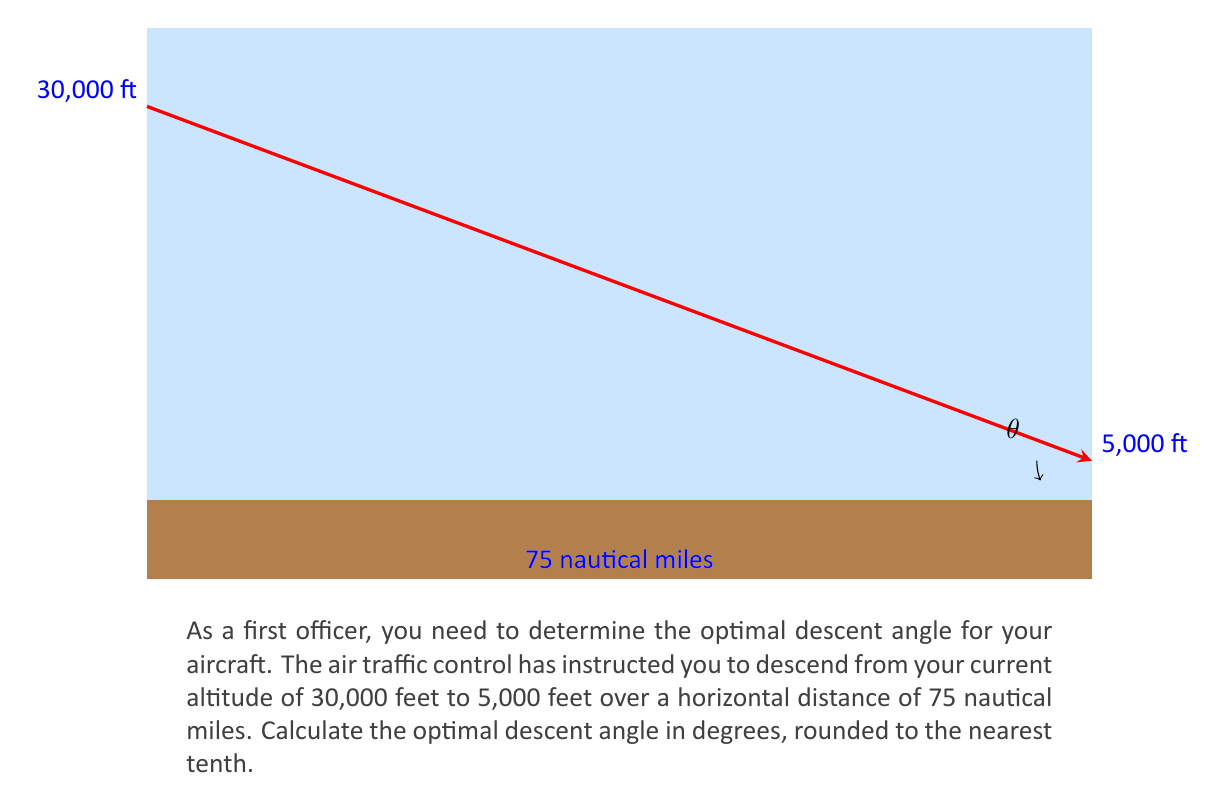Help me with this question. Let's approach this step-by-step:

1) First, we need to identify the relevant trigonometric relationship. In this case, we're looking at a right triangle where:
   - The opposite side is the change in altitude
   - The adjacent side is the horizontal distance
   - The angle we're seeking is the descent angle

2) The trigonometric function that relates the opposite side to the adjacent side is the tangent function.

3) Let's set up our equation:
   $$\tan(\theta) = \frac{\text{opposite}}{\text{adjacent}} = \frac{\text{change in altitude}}{\text{horizontal distance}}$$

4) Calculate the change in altitude:
   $30,000 \text{ ft} - 5,000 \text{ ft} = 25,000 \text{ ft}$

5) The horizontal distance is given as 75 nautical miles. We need to convert this to feet:
   $75 \text{ nautical miles} = 75 \times 6,076.12 \text{ ft} = 455,709 \text{ ft}$

6) Now we can plug these values into our equation:
   $$\tan(\theta) = \frac{25,000 \text{ ft}}{455,709 \text{ ft}}$$

7) Solve for $\theta$:
   $$\theta = \arctan(\frac{25,000}{455,709}) \approx 3.14159 \text{ degrees}$$

8) Rounding to the nearest tenth:
   $$\theta \approx 3.1 \text{ degrees}$$
Answer: $3.1°$ 